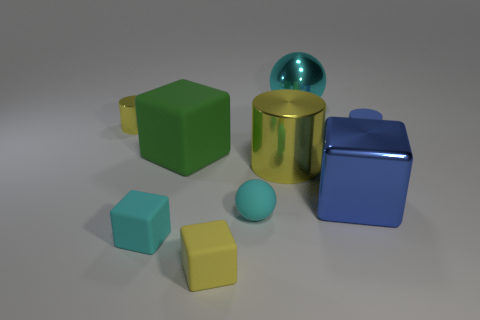Add 1 yellow rubber blocks. How many objects exist? 10 Subtract all cubes. How many objects are left? 5 Add 9 blue cylinders. How many blue cylinders are left? 10 Add 2 tiny metal things. How many tiny metal things exist? 3 Subtract 0 red cubes. How many objects are left? 9 Subtract all small yellow objects. Subtract all large yellow matte objects. How many objects are left? 7 